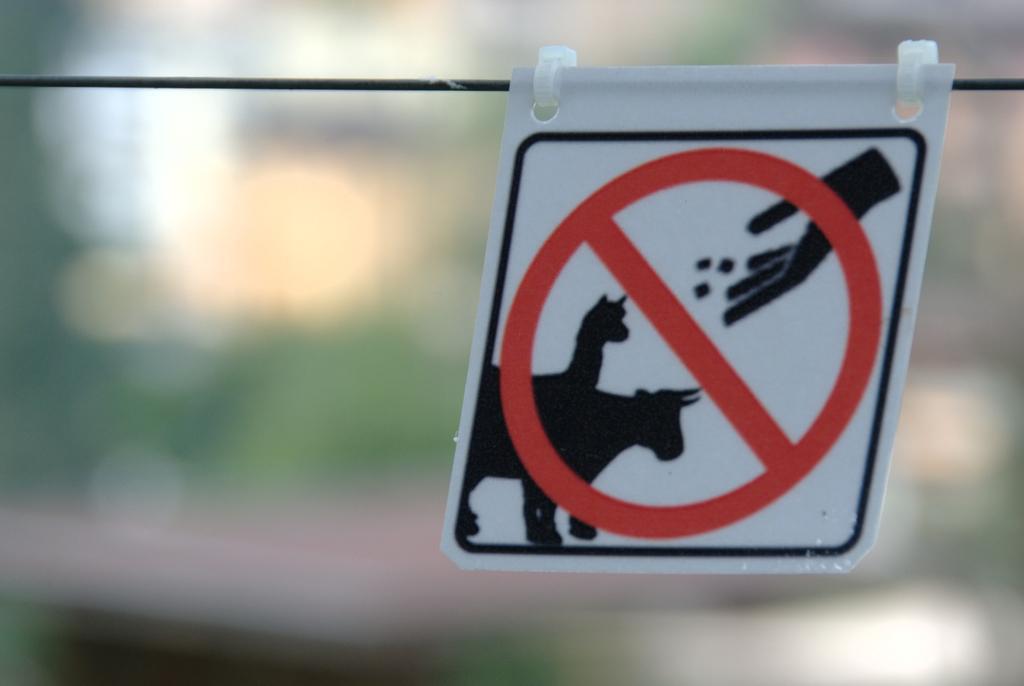Describe this image in one or two sentences. In this image we can see there is a danger sign board attached to the rope. 